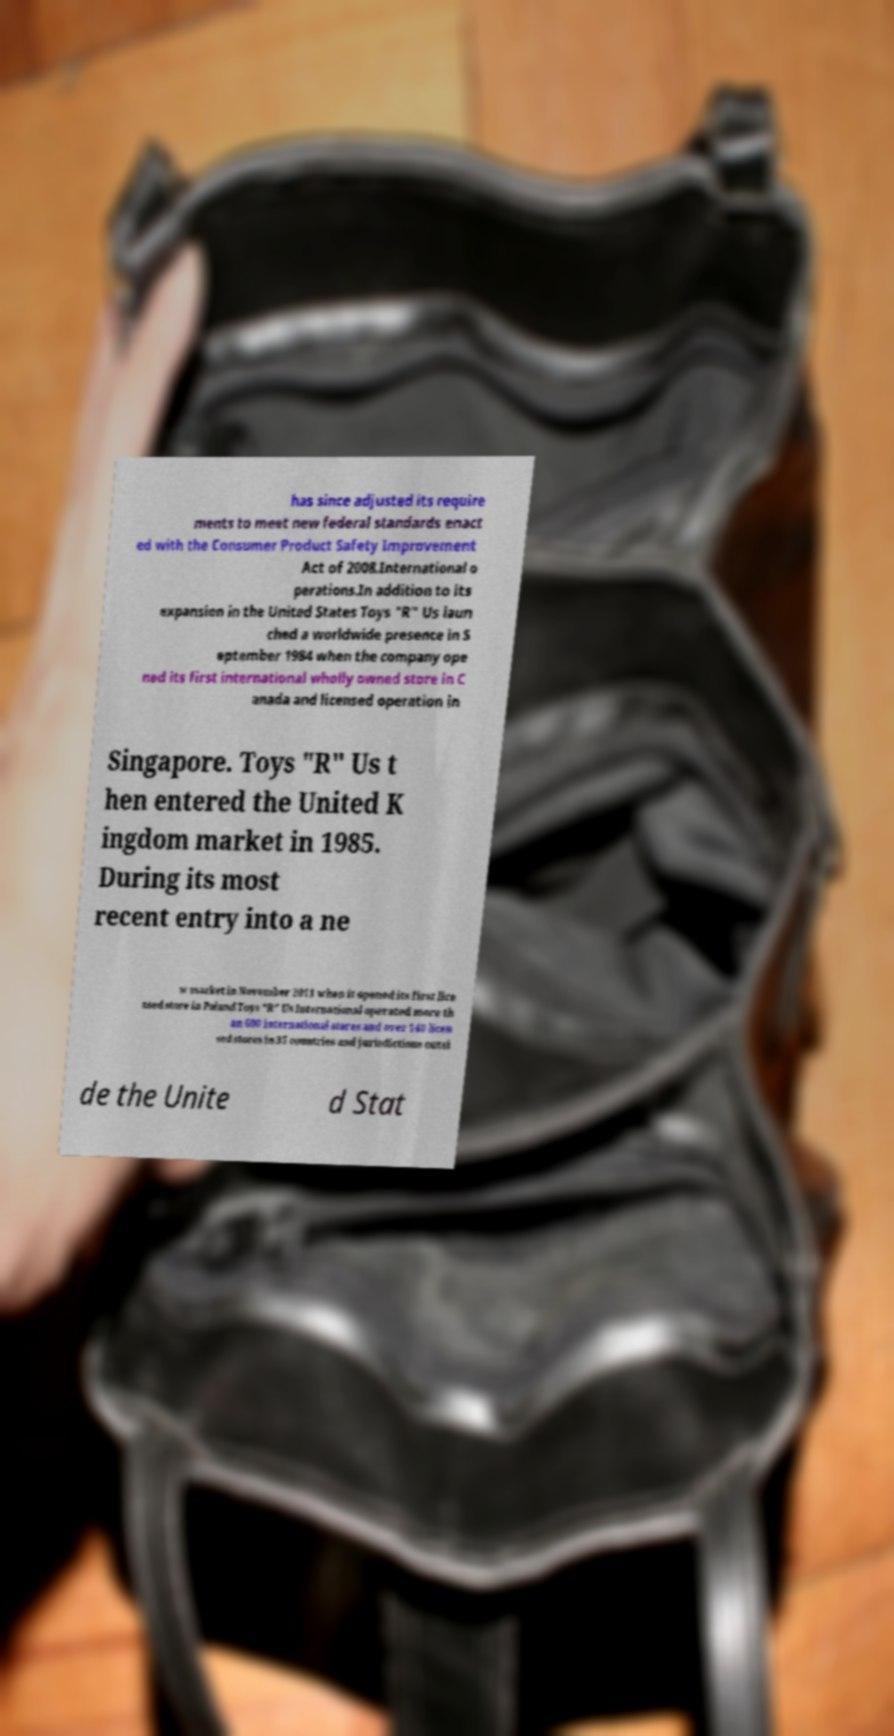Could you extract and type out the text from this image? has since adjusted its require ments to meet new federal standards enact ed with the Consumer Product Safety Improvement Act of 2008.International o perations.In addition to its expansion in the United States Toys "R" Us laun ched a worldwide presence in S eptember 1984 when the company ope ned its first international wholly owned store in C anada and licensed operation in Singapore. Toys "R" Us t hen entered the United K ingdom market in 1985. During its most recent entry into a ne w market in November 2011 when it opened its first lice nsed store in Poland Toys "R" Us International operated more th an 600 international stores and over 140 licen sed stores in 35 countries and jurisdictions outsi de the Unite d Stat 